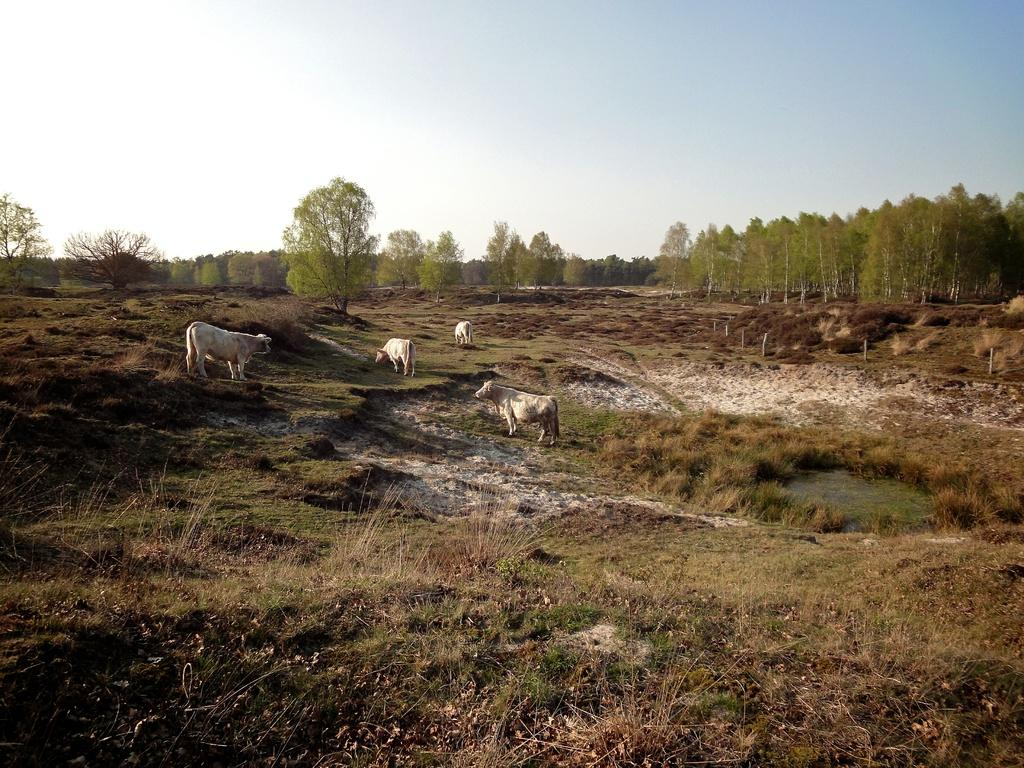What animals are present on the ground in the image? There are cattle on the ground in the image. What can be seen in the background of the image? There are trees in the background of the image. What is visible in the sky in the image? The sky is visible in the image, and it contains clouds. How many pigs are sitting on the spot in the image? There are no pigs present in the image, and there is no spot mentioned. 